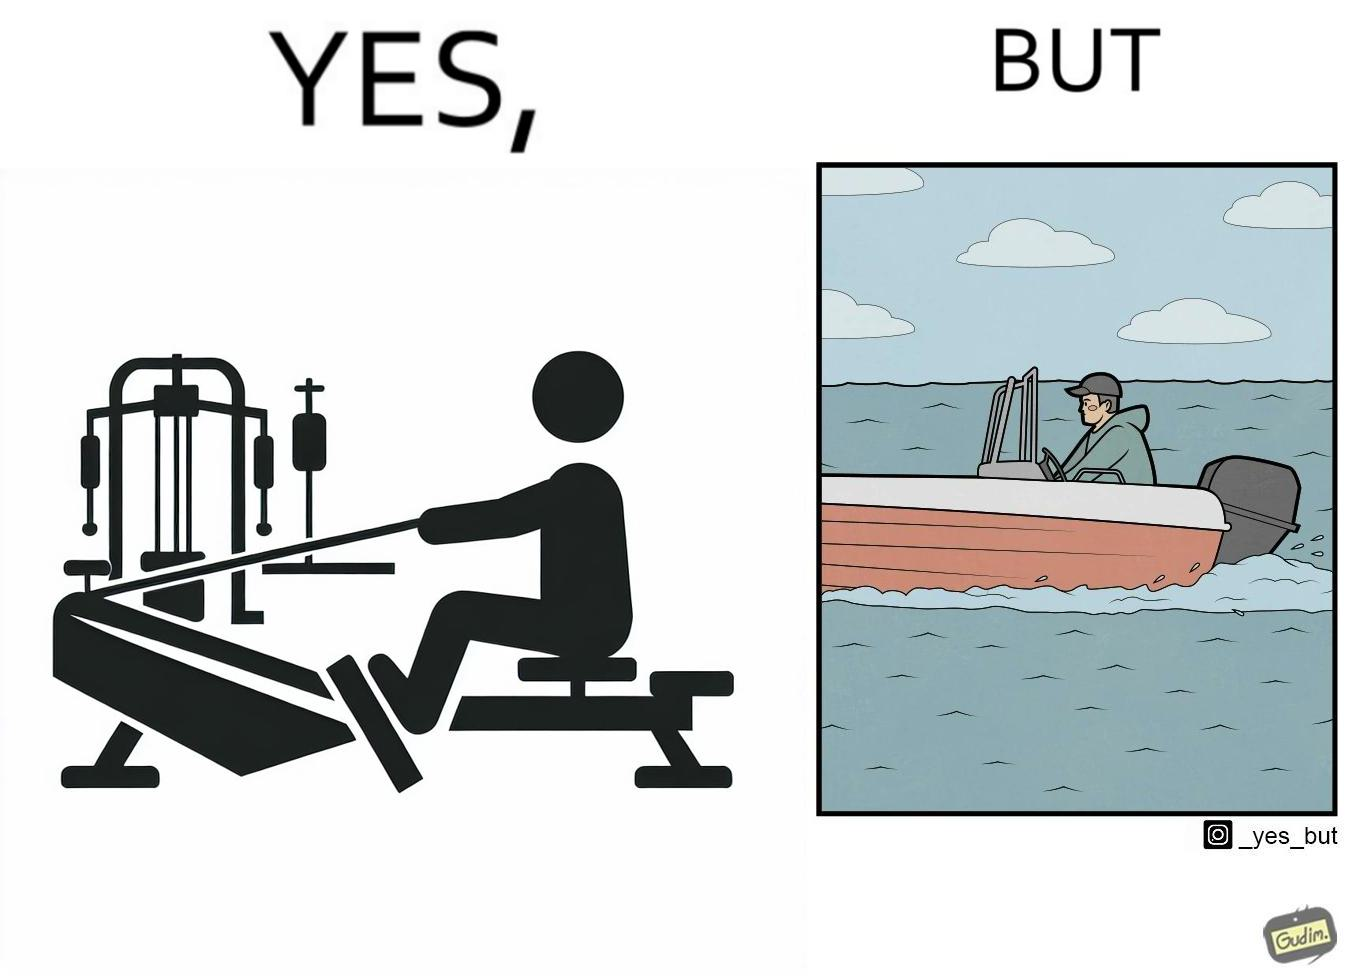Describe the content of this image. The image is ironic, because people often use rowing machine at the gym don't prefer rowing when it comes to boats 